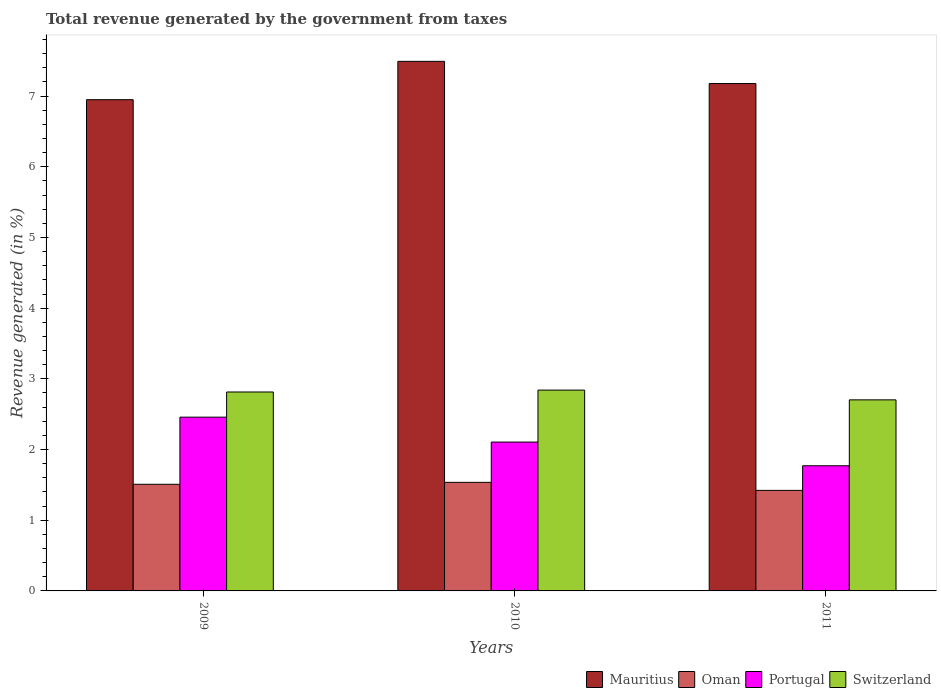How many groups of bars are there?
Your answer should be compact. 3. How many bars are there on the 1st tick from the left?
Give a very brief answer. 4. How many bars are there on the 3rd tick from the right?
Provide a short and direct response. 4. In how many cases, is the number of bars for a given year not equal to the number of legend labels?
Your response must be concise. 0. What is the total revenue generated in Mauritius in 2011?
Provide a short and direct response. 7.18. Across all years, what is the maximum total revenue generated in Oman?
Your response must be concise. 1.54. Across all years, what is the minimum total revenue generated in Oman?
Your answer should be compact. 1.42. What is the total total revenue generated in Portugal in the graph?
Give a very brief answer. 6.33. What is the difference between the total revenue generated in Portugal in 2010 and that in 2011?
Your answer should be compact. 0.34. What is the difference between the total revenue generated in Portugal in 2010 and the total revenue generated in Mauritius in 2009?
Your answer should be very brief. -4.84. What is the average total revenue generated in Oman per year?
Make the answer very short. 1.49. In the year 2011, what is the difference between the total revenue generated in Portugal and total revenue generated in Oman?
Provide a short and direct response. 0.35. In how many years, is the total revenue generated in Switzerland greater than 3.4 %?
Ensure brevity in your answer.  0. What is the ratio of the total revenue generated in Switzerland in 2009 to that in 2010?
Ensure brevity in your answer.  0.99. What is the difference between the highest and the second highest total revenue generated in Oman?
Provide a succinct answer. 0.03. What is the difference between the highest and the lowest total revenue generated in Switzerland?
Your answer should be very brief. 0.14. What does the 1st bar from the left in 2009 represents?
Your response must be concise. Mauritius. What does the 4th bar from the right in 2010 represents?
Your answer should be compact. Mauritius. Is it the case that in every year, the sum of the total revenue generated in Portugal and total revenue generated in Mauritius is greater than the total revenue generated in Oman?
Provide a short and direct response. Yes. How many bars are there?
Offer a terse response. 12. Are all the bars in the graph horizontal?
Your answer should be very brief. No. Are the values on the major ticks of Y-axis written in scientific E-notation?
Ensure brevity in your answer.  No. Does the graph contain any zero values?
Your response must be concise. No. Does the graph contain grids?
Make the answer very short. No. What is the title of the graph?
Provide a succinct answer. Total revenue generated by the government from taxes. Does "Finland" appear as one of the legend labels in the graph?
Your answer should be very brief. No. What is the label or title of the X-axis?
Keep it short and to the point. Years. What is the label or title of the Y-axis?
Your answer should be compact. Revenue generated (in %). What is the Revenue generated (in %) in Mauritius in 2009?
Your answer should be very brief. 6.95. What is the Revenue generated (in %) in Oman in 2009?
Provide a succinct answer. 1.51. What is the Revenue generated (in %) in Portugal in 2009?
Your answer should be very brief. 2.46. What is the Revenue generated (in %) of Switzerland in 2009?
Your response must be concise. 2.81. What is the Revenue generated (in %) of Mauritius in 2010?
Provide a succinct answer. 7.49. What is the Revenue generated (in %) in Oman in 2010?
Offer a very short reply. 1.54. What is the Revenue generated (in %) in Portugal in 2010?
Offer a very short reply. 2.11. What is the Revenue generated (in %) of Switzerland in 2010?
Provide a succinct answer. 2.84. What is the Revenue generated (in %) of Mauritius in 2011?
Offer a terse response. 7.18. What is the Revenue generated (in %) in Oman in 2011?
Provide a short and direct response. 1.42. What is the Revenue generated (in %) in Portugal in 2011?
Offer a terse response. 1.77. What is the Revenue generated (in %) in Switzerland in 2011?
Keep it short and to the point. 2.7. Across all years, what is the maximum Revenue generated (in %) in Mauritius?
Your answer should be compact. 7.49. Across all years, what is the maximum Revenue generated (in %) of Oman?
Provide a succinct answer. 1.54. Across all years, what is the maximum Revenue generated (in %) in Portugal?
Make the answer very short. 2.46. Across all years, what is the maximum Revenue generated (in %) of Switzerland?
Keep it short and to the point. 2.84. Across all years, what is the minimum Revenue generated (in %) of Mauritius?
Your answer should be compact. 6.95. Across all years, what is the minimum Revenue generated (in %) of Oman?
Provide a short and direct response. 1.42. Across all years, what is the minimum Revenue generated (in %) in Portugal?
Your answer should be compact. 1.77. Across all years, what is the minimum Revenue generated (in %) in Switzerland?
Offer a terse response. 2.7. What is the total Revenue generated (in %) of Mauritius in the graph?
Provide a succinct answer. 21.62. What is the total Revenue generated (in %) of Oman in the graph?
Keep it short and to the point. 4.47. What is the total Revenue generated (in %) in Portugal in the graph?
Provide a succinct answer. 6.33. What is the total Revenue generated (in %) in Switzerland in the graph?
Give a very brief answer. 8.36. What is the difference between the Revenue generated (in %) of Mauritius in 2009 and that in 2010?
Provide a short and direct response. -0.54. What is the difference between the Revenue generated (in %) in Oman in 2009 and that in 2010?
Make the answer very short. -0.03. What is the difference between the Revenue generated (in %) in Portugal in 2009 and that in 2010?
Your response must be concise. 0.35. What is the difference between the Revenue generated (in %) of Switzerland in 2009 and that in 2010?
Offer a terse response. -0.03. What is the difference between the Revenue generated (in %) of Mauritius in 2009 and that in 2011?
Ensure brevity in your answer.  -0.23. What is the difference between the Revenue generated (in %) in Oman in 2009 and that in 2011?
Your answer should be compact. 0.09. What is the difference between the Revenue generated (in %) of Portugal in 2009 and that in 2011?
Provide a succinct answer. 0.69. What is the difference between the Revenue generated (in %) in Mauritius in 2010 and that in 2011?
Make the answer very short. 0.31. What is the difference between the Revenue generated (in %) in Oman in 2010 and that in 2011?
Offer a very short reply. 0.11. What is the difference between the Revenue generated (in %) of Portugal in 2010 and that in 2011?
Provide a succinct answer. 0.34. What is the difference between the Revenue generated (in %) in Switzerland in 2010 and that in 2011?
Your answer should be compact. 0.14. What is the difference between the Revenue generated (in %) in Mauritius in 2009 and the Revenue generated (in %) in Oman in 2010?
Offer a very short reply. 5.41. What is the difference between the Revenue generated (in %) in Mauritius in 2009 and the Revenue generated (in %) in Portugal in 2010?
Your answer should be compact. 4.84. What is the difference between the Revenue generated (in %) in Mauritius in 2009 and the Revenue generated (in %) in Switzerland in 2010?
Give a very brief answer. 4.11. What is the difference between the Revenue generated (in %) of Oman in 2009 and the Revenue generated (in %) of Portugal in 2010?
Offer a very short reply. -0.6. What is the difference between the Revenue generated (in %) of Oman in 2009 and the Revenue generated (in %) of Switzerland in 2010?
Keep it short and to the point. -1.33. What is the difference between the Revenue generated (in %) in Portugal in 2009 and the Revenue generated (in %) in Switzerland in 2010?
Offer a very short reply. -0.38. What is the difference between the Revenue generated (in %) in Mauritius in 2009 and the Revenue generated (in %) in Oman in 2011?
Your response must be concise. 5.53. What is the difference between the Revenue generated (in %) in Mauritius in 2009 and the Revenue generated (in %) in Portugal in 2011?
Make the answer very short. 5.18. What is the difference between the Revenue generated (in %) of Mauritius in 2009 and the Revenue generated (in %) of Switzerland in 2011?
Provide a succinct answer. 4.25. What is the difference between the Revenue generated (in %) of Oman in 2009 and the Revenue generated (in %) of Portugal in 2011?
Ensure brevity in your answer.  -0.26. What is the difference between the Revenue generated (in %) in Oman in 2009 and the Revenue generated (in %) in Switzerland in 2011?
Your answer should be compact. -1.19. What is the difference between the Revenue generated (in %) in Portugal in 2009 and the Revenue generated (in %) in Switzerland in 2011?
Keep it short and to the point. -0.24. What is the difference between the Revenue generated (in %) of Mauritius in 2010 and the Revenue generated (in %) of Oman in 2011?
Your response must be concise. 6.07. What is the difference between the Revenue generated (in %) of Mauritius in 2010 and the Revenue generated (in %) of Portugal in 2011?
Make the answer very short. 5.72. What is the difference between the Revenue generated (in %) of Mauritius in 2010 and the Revenue generated (in %) of Switzerland in 2011?
Offer a terse response. 4.79. What is the difference between the Revenue generated (in %) in Oman in 2010 and the Revenue generated (in %) in Portugal in 2011?
Provide a short and direct response. -0.23. What is the difference between the Revenue generated (in %) of Oman in 2010 and the Revenue generated (in %) of Switzerland in 2011?
Offer a terse response. -1.17. What is the difference between the Revenue generated (in %) of Portugal in 2010 and the Revenue generated (in %) of Switzerland in 2011?
Your answer should be compact. -0.6. What is the average Revenue generated (in %) in Mauritius per year?
Keep it short and to the point. 7.21. What is the average Revenue generated (in %) in Oman per year?
Your answer should be compact. 1.49. What is the average Revenue generated (in %) of Portugal per year?
Your response must be concise. 2.11. What is the average Revenue generated (in %) in Switzerland per year?
Keep it short and to the point. 2.79. In the year 2009, what is the difference between the Revenue generated (in %) of Mauritius and Revenue generated (in %) of Oman?
Your answer should be compact. 5.44. In the year 2009, what is the difference between the Revenue generated (in %) in Mauritius and Revenue generated (in %) in Portugal?
Your answer should be very brief. 4.49. In the year 2009, what is the difference between the Revenue generated (in %) in Mauritius and Revenue generated (in %) in Switzerland?
Ensure brevity in your answer.  4.13. In the year 2009, what is the difference between the Revenue generated (in %) in Oman and Revenue generated (in %) in Portugal?
Offer a terse response. -0.95. In the year 2009, what is the difference between the Revenue generated (in %) in Oman and Revenue generated (in %) in Switzerland?
Your response must be concise. -1.31. In the year 2009, what is the difference between the Revenue generated (in %) of Portugal and Revenue generated (in %) of Switzerland?
Keep it short and to the point. -0.36. In the year 2010, what is the difference between the Revenue generated (in %) of Mauritius and Revenue generated (in %) of Oman?
Your answer should be very brief. 5.96. In the year 2010, what is the difference between the Revenue generated (in %) of Mauritius and Revenue generated (in %) of Portugal?
Provide a succinct answer. 5.39. In the year 2010, what is the difference between the Revenue generated (in %) of Mauritius and Revenue generated (in %) of Switzerland?
Your answer should be compact. 4.65. In the year 2010, what is the difference between the Revenue generated (in %) of Oman and Revenue generated (in %) of Portugal?
Make the answer very short. -0.57. In the year 2010, what is the difference between the Revenue generated (in %) in Oman and Revenue generated (in %) in Switzerland?
Give a very brief answer. -1.3. In the year 2010, what is the difference between the Revenue generated (in %) in Portugal and Revenue generated (in %) in Switzerland?
Make the answer very short. -0.74. In the year 2011, what is the difference between the Revenue generated (in %) of Mauritius and Revenue generated (in %) of Oman?
Provide a succinct answer. 5.75. In the year 2011, what is the difference between the Revenue generated (in %) in Mauritius and Revenue generated (in %) in Portugal?
Give a very brief answer. 5.41. In the year 2011, what is the difference between the Revenue generated (in %) of Mauritius and Revenue generated (in %) of Switzerland?
Your answer should be very brief. 4.47. In the year 2011, what is the difference between the Revenue generated (in %) in Oman and Revenue generated (in %) in Portugal?
Keep it short and to the point. -0.35. In the year 2011, what is the difference between the Revenue generated (in %) in Oman and Revenue generated (in %) in Switzerland?
Provide a short and direct response. -1.28. In the year 2011, what is the difference between the Revenue generated (in %) in Portugal and Revenue generated (in %) in Switzerland?
Your response must be concise. -0.93. What is the ratio of the Revenue generated (in %) in Mauritius in 2009 to that in 2010?
Provide a succinct answer. 0.93. What is the ratio of the Revenue generated (in %) of Oman in 2009 to that in 2010?
Make the answer very short. 0.98. What is the ratio of the Revenue generated (in %) in Portugal in 2009 to that in 2010?
Keep it short and to the point. 1.17. What is the ratio of the Revenue generated (in %) of Mauritius in 2009 to that in 2011?
Your answer should be very brief. 0.97. What is the ratio of the Revenue generated (in %) in Oman in 2009 to that in 2011?
Provide a succinct answer. 1.06. What is the ratio of the Revenue generated (in %) of Portugal in 2009 to that in 2011?
Keep it short and to the point. 1.39. What is the ratio of the Revenue generated (in %) of Switzerland in 2009 to that in 2011?
Offer a very short reply. 1.04. What is the ratio of the Revenue generated (in %) in Mauritius in 2010 to that in 2011?
Make the answer very short. 1.04. What is the ratio of the Revenue generated (in %) in Oman in 2010 to that in 2011?
Ensure brevity in your answer.  1.08. What is the ratio of the Revenue generated (in %) of Portugal in 2010 to that in 2011?
Provide a short and direct response. 1.19. What is the ratio of the Revenue generated (in %) of Switzerland in 2010 to that in 2011?
Your answer should be very brief. 1.05. What is the difference between the highest and the second highest Revenue generated (in %) of Mauritius?
Make the answer very short. 0.31. What is the difference between the highest and the second highest Revenue generated (in %) of Oman?
Provide a succinct answer. 0.03. What is the difference between the highest and the second highest Revenue generated (in %) in Portugal?
Your answer should be very brief. 0.35. What is the difference between the highest and the second highest Revenue generated (in %) of Switzerland?
Your answer should be very brief. 0.03. What is the difference between the highest and the lowest Revenue generated (in %) in Mauritius?
Give a very brief answer. 0.54. What is the difference between the highest and the lowest Revenue generated (in %) of Oman?
Offer a very short reply. 0.11. What is the difference between the highest and the lowest Revenue generated (in %) in Portugal?
Provide a short and direct response. 0.69. What is the difference between the highest and the lowest Revenue generated (in %) of Switzerland?
Make the answer very short. 0.14. 